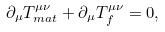Convert formula to latex. <formula><loc_0><loc_0><loc_500><loc_500>\partial _ { \mu } T ^ { \mu \nu } _ { m a t } + \partial _ { \mu } T ^ { \mu \nu } _ { f } = 0 ,</formula> 